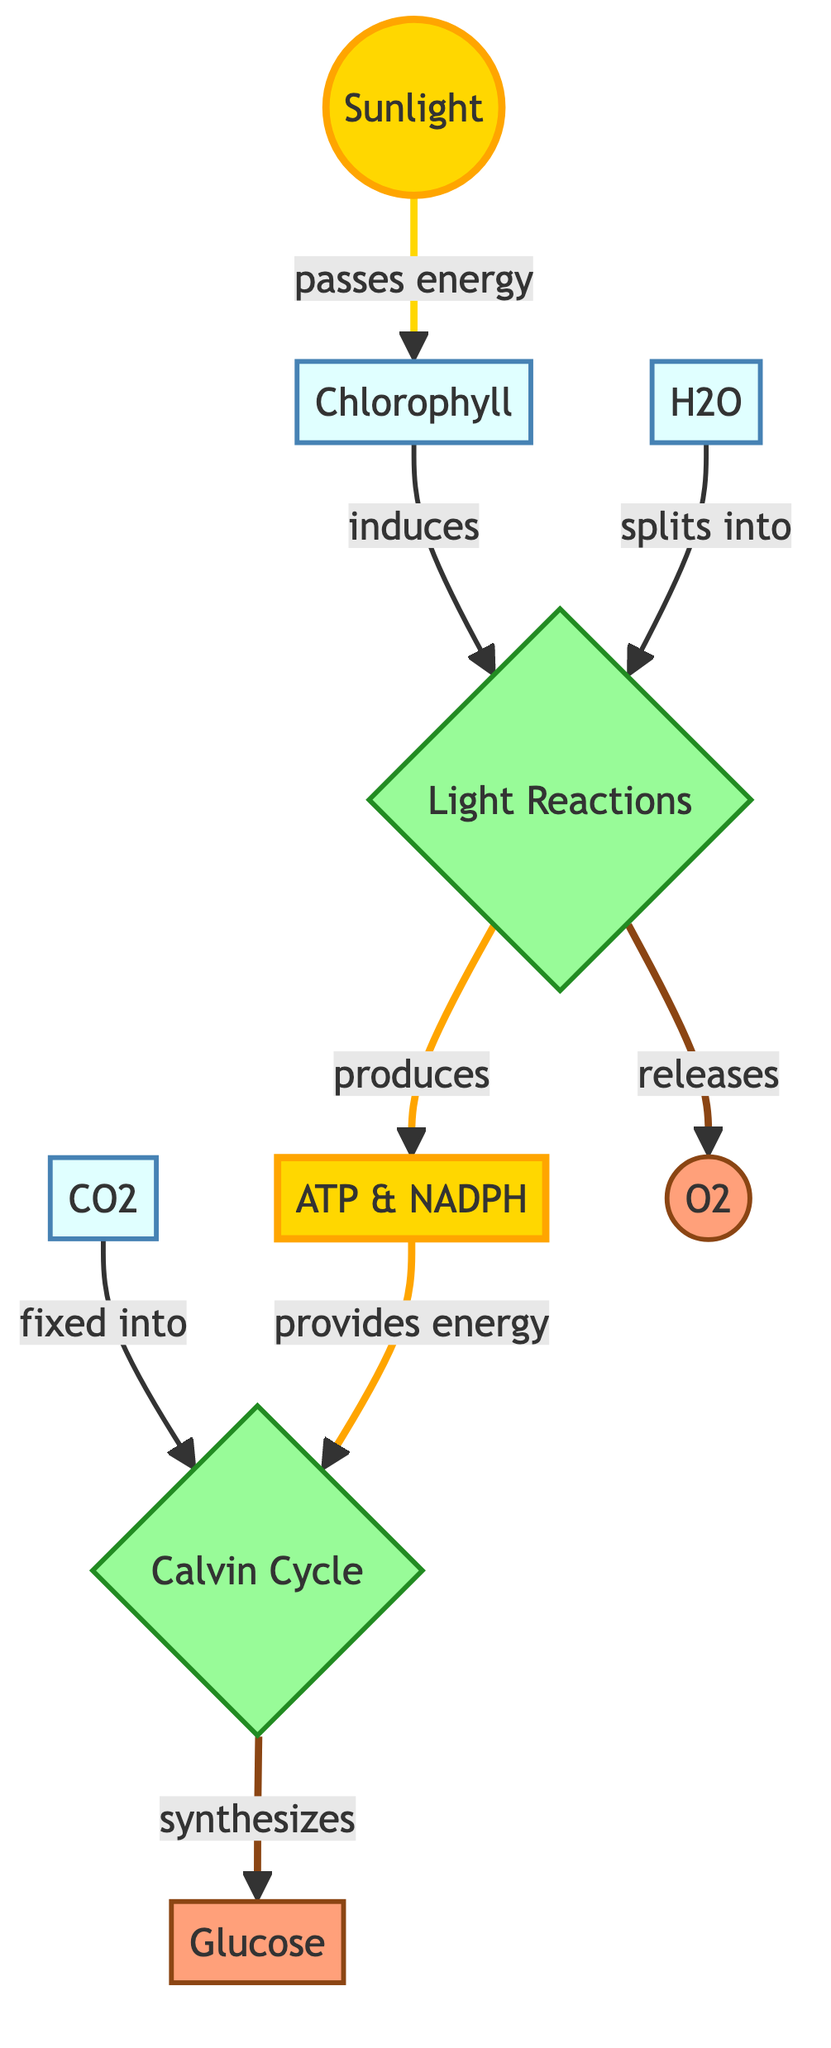What's produced in the light reactions? The diagram indicates that the light reactions produce ATP and NADPH. This is observed from the arrow leading from light reactions to ATP & NADPH, which is labeled "produces."
Answer: ATP & NADPH How many molecules are involved in the process? By counting all the distinct labeled nodes in the diagram, we have Sunlight, Chlorophyll, H2O, CO2, Light Reactions, ATP & NADPH, Calvin Cycle, Glucose, and O2, totaling nine molecules.
Answer: 9 What is the function of chlorophyll in photosynthesis? The diagram shows that chlorophyll passes energy to initiate the light reactions. This can be seen from the arrow linking sunlight to chlorophyll and then to light reactions, labeled "induces."
Answer: induces Which process follows the light reactions? The flow of the diagram shows that after light reactions, carbon dioxide is fixed into the Calvin Cycle. This is derived from the arrow pointing from light reactions to calvin_cycle that connects the two processes.
Answer: Calvin Cycle What gas is released during photosynthesis? From the diagram, it is evident that the light reactions release oxygen, as indicated by the arrow leading from light reactions to oxygen, labeled "releases."
Answer: O2 How does ATP & NADPH contribute to the Calvin Cycle? ATP and NADPH provide energy for the Calvin Cycle as illustrated by the arrow from ATP & NADPH to calvin_cycle labeled "provides energy," indicating a supportive role in the synthesis of glucose.
Answer: provides energy What splits into the light reactions? The diagram specifies that water (H2O) splits into the light reactions. This is seen through the direct arrow that reads "splits into" from water to light reactions.
Answer: H2O Which product is synthesized in the Calvin Cycle? The output of the Calvin Cycle, as depicted in the diagram, is glucose, which is indicated by the arrow going from calvin_cycle to glucose and labeled "synthesizes."
Answer: Glucose What element of energy is invoked from sunlight? The diagram details that sunlight is an energy source that is passed to chlorophyll, as indicated by the direction of flow marked "passes energy," showcasing its fundamental role in the initiation of photosynthesis.
Answer: energy 